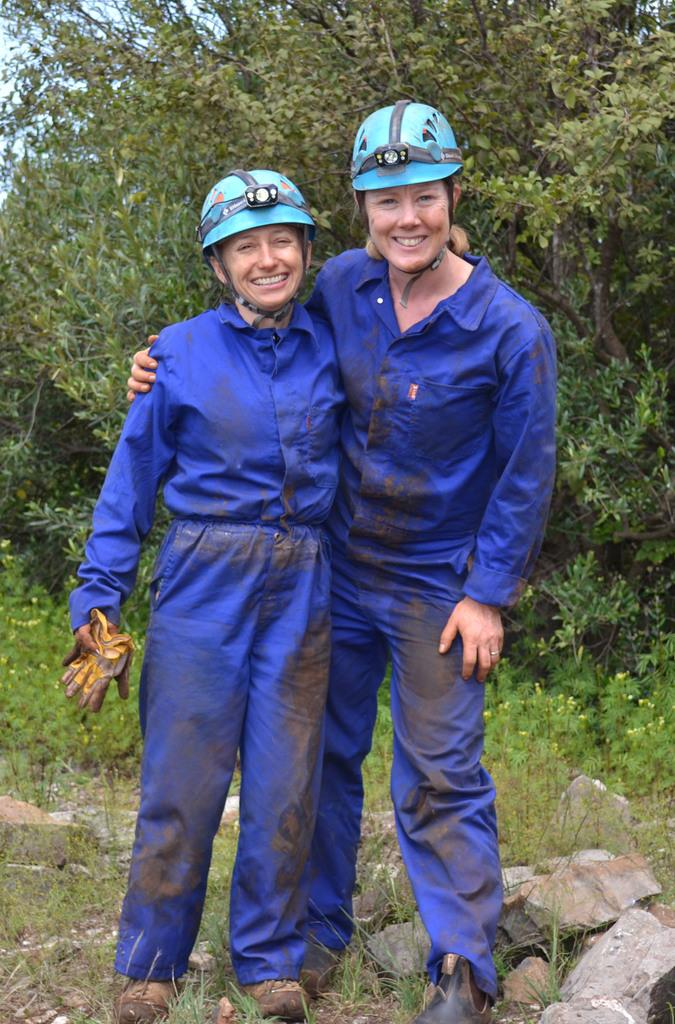How many people are present in the image? There are two people in the image. What is the facial expression of the people in the image? Both people are smiling. What can be seen in the background of the image? There are trees and plants in the background of the image. What type of oven is visible in the image? There is no oven present in the image. What kind of paper can be seen on the ground in the image? There is no paper visible on the ground in the image. 